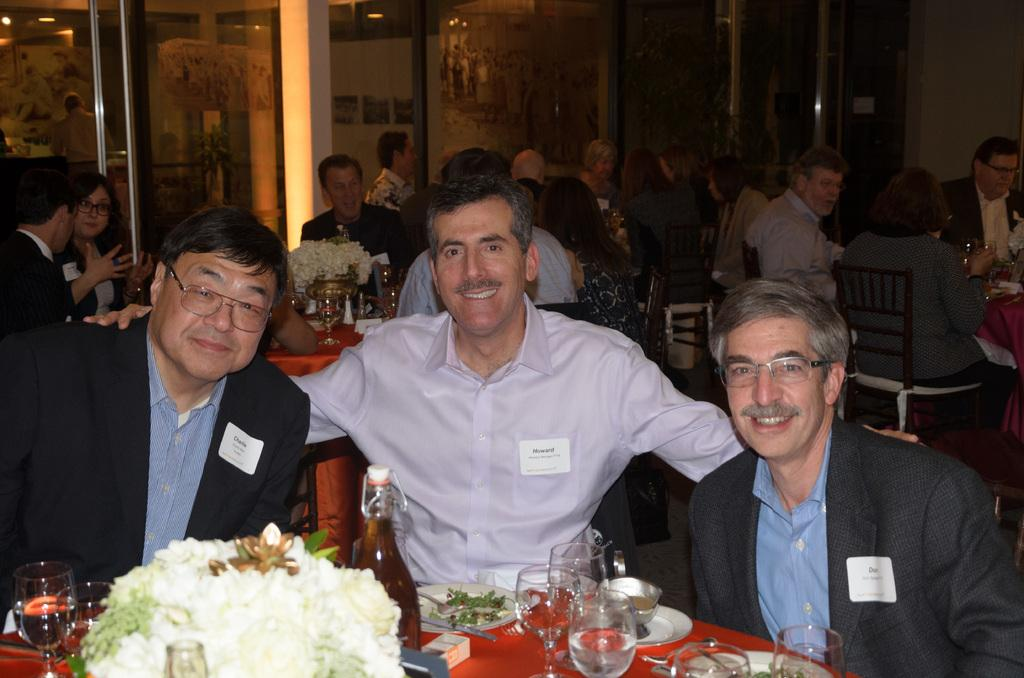How many men are in the image? There are three men in the image. What are the men doing in the image? The men are sitting in the image. What is in front of the men? There is a table in front of the men. Are there any other people in the image? Yes, there are people sitting behind the men. What date is circled on the calendar in the image? There is no calendar present in the image. How much is the dime on the table worth in the image? There is no dime present in the image. 